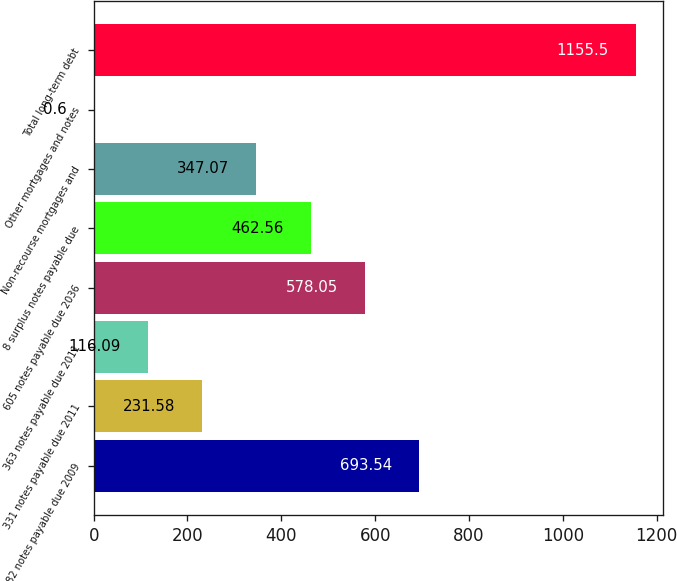<chart> <loc_0><loc_0><loc_500><loc_500><bar_chart><fcel>82 notes payable due 2009<fcel>331 notes payable due 2011<fcel>363 notes payable due 2011<fcel>605 notes payable due 2036<fcel>8 surplus notes payable due<fcel>Non-recourse mortgages and<fcel>Other mortgages and notes<fcel>Total long-term debt<nl><fcel>693.54<fcel>231.58<fcel>116.09<fcel>578.05<fcel>462.56<fcel>347.07<fcel>0.6<fcel>1155.5<nl></chart> 